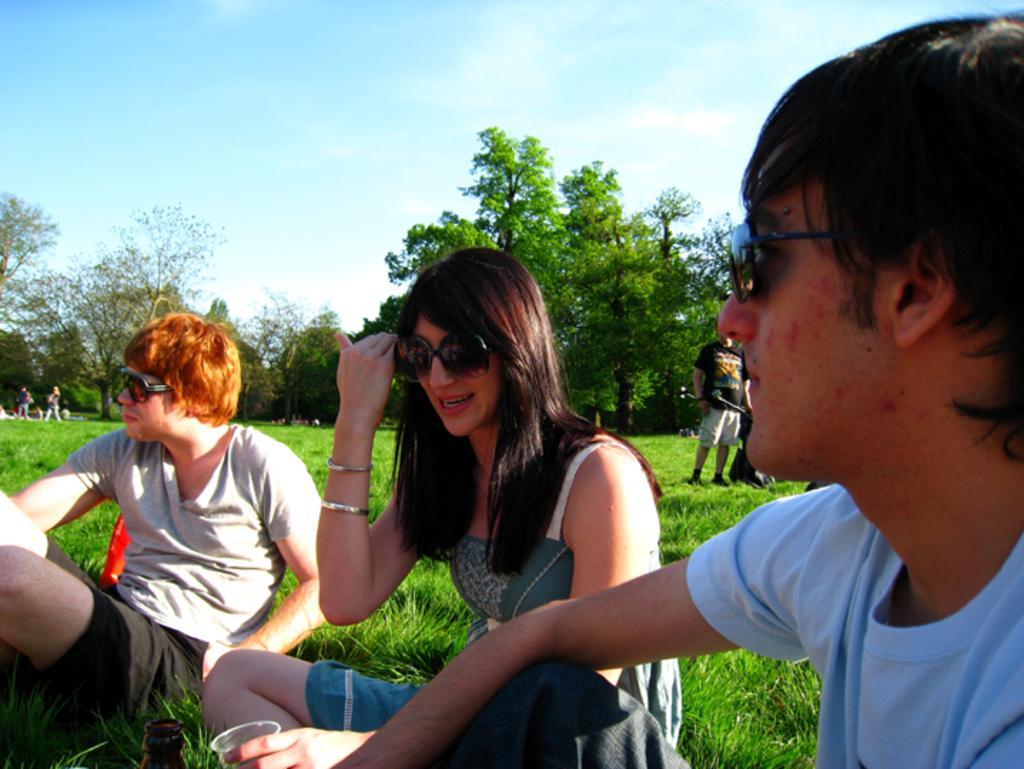In one or two sentences, can you explain what this image depicts? In this image we can see many people. Some are sitting. They are wearing goggles. On the ground there is grass. In the back there are trees and there is sky with clouds. 